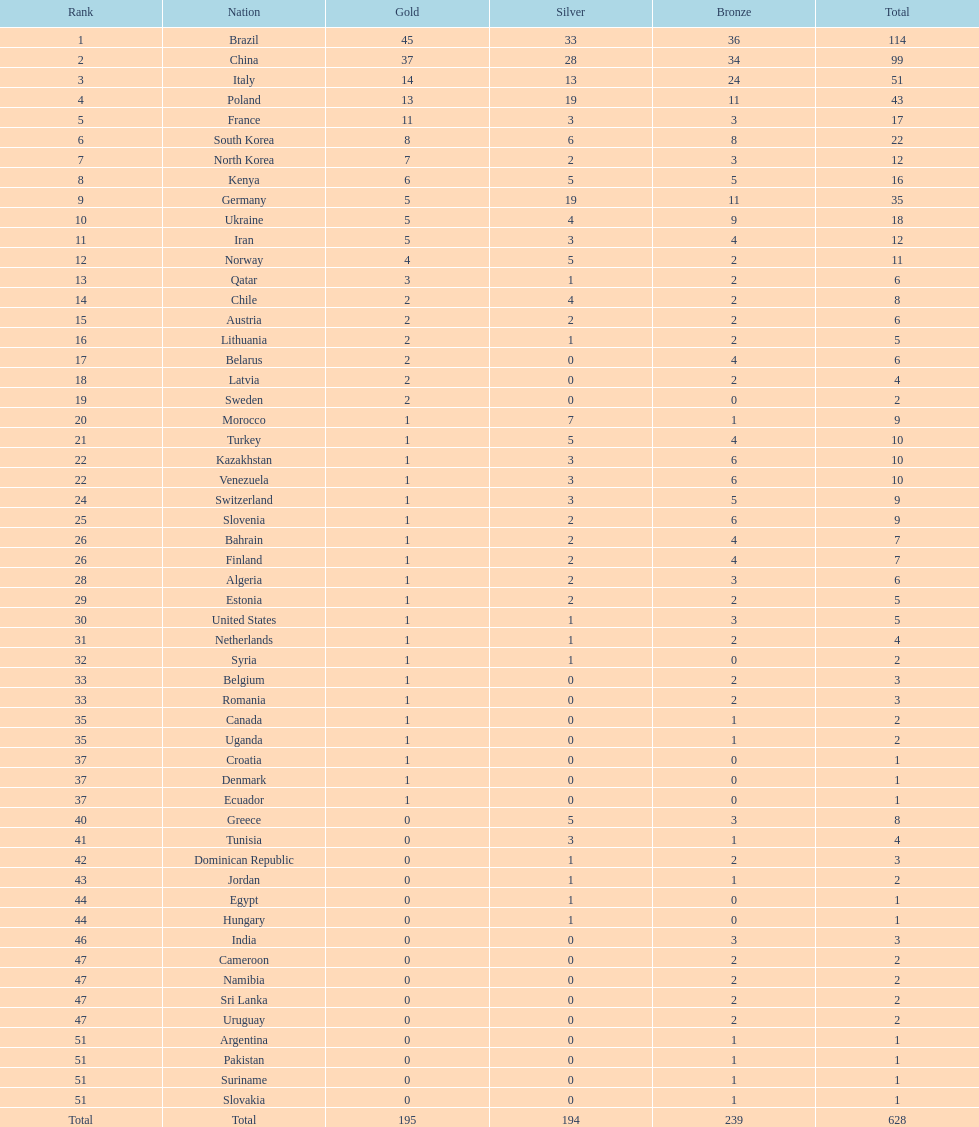How many medals has norway won in total? 11. 